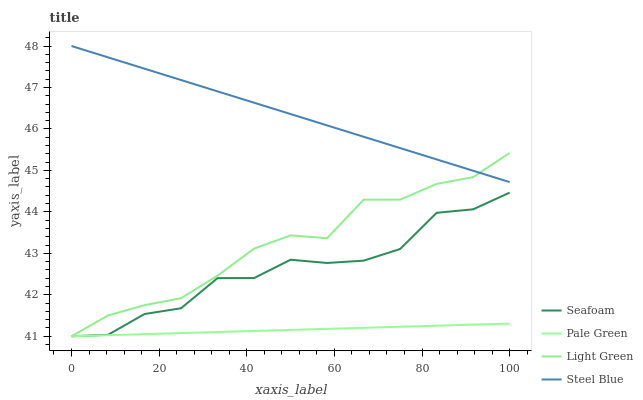Does Pale Green have the minimum area under the curve?
Answer yes or no. Yes. Does Steel Blue have the maximum area under the curve?
Answer yes or no. Yes. Does Seafoam have the minimum area under the curve?
Answer yes or no. No. Does Seafoam have the maximum area under the curve?
Answer yes or no. No. Is Steel Blue the smoothest?
Answer yes or no. Yes. Is Seafoam the roughest?
Answer yes or no. Yes. Is Light Green the smoothest?
Answer yes or no. No. Is Light Green the roughest?
Answer yes or no. No. Does Pale Green have the lowest value?
Answer yes or no. Yes. Does Steel Blue have the lowest value?
Answer yes or no. No. Does Steel Blue have the highest value?
Answer yes or no. Yes. Does Seafoam have the highest value?
Answer yes or no. No. Is Pale Green less than Steel Blue?
Answer yes or no. Yes. Is Steel Blue greater than Pale Green?
Answer yes or no. Yes. Does Steel Blue intersect Light Green?
Answer yes or no. Yes. Is Steel Blue less than Light Green?
Answer yes or no. No. Is Steel Blue greater than Light Green?
Answer yes or no. No. Does Pale Green intersect Steel Blue?
Answer yes or no. No. 